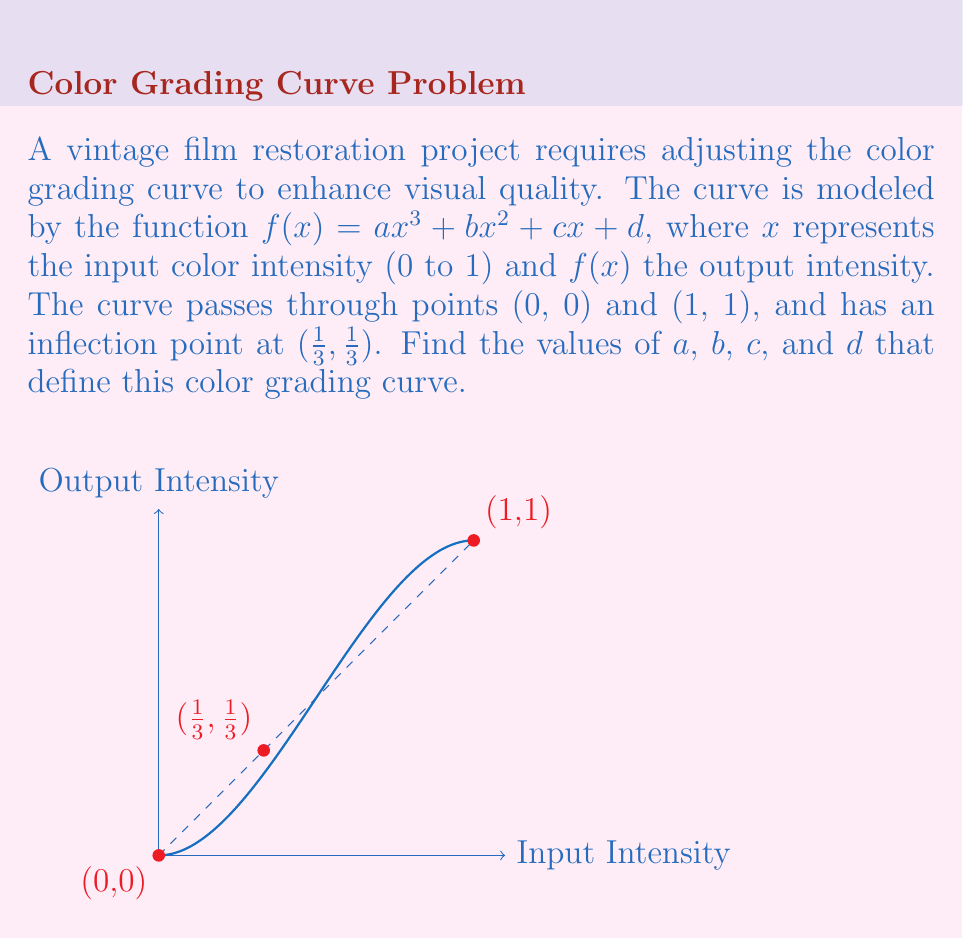Can you solve this math problem? Let's approach this step-by-step:

1) First, we use the condition that the curve passes through (0, 0):
   $f(0) = a(0)^3 + b(0)^2 + c(0) + d = 0$
   This implies $d = 0$

2) Next, we use the condition that the curve passes through (1, 1):
   $f(1) = a(1)^3 + b(1)^2 + c(1) + 0 = 1$
   $a + b + c = 1$ ... (Equation 1)

3) For the inflection point at $(\frac{1}{3}, \frac{1}{3})$, we need:
   $f(\frac{1}{3}) = \frac{1}{3}$
   $a(\frac{1}{3})^3 + b(\frac{1}{3})^2 + c(\frac{1}{3}) = \frac{1}{3}$
   $\frac{a}{27} + \frac{b}{9} + \frac{c}{3} = \frac{1}{3}$ ... (Equation 2)

4) At the inflection point, the second derivative should be zero:
   $f''(x) = 6ax + 2b$
   $f''(\frac{1}{3}) = 6a(\frac{1}{3}) + 2b = 0$
   $2a + 2b = 0$
   $a = -b$ ... (Equation 3)

5) From Equation 3, substitute $b = -a$ into Equation 1:
   $a - a + c = 1$
   $c = 1$ ... (Equation 4)

6) Substitute Equations 3 and 4 into Equation 2:
   $\frac{a}{27} - \frac{a}{9} + \frac{1}{3} = \frac{1}{3}$
   $\frac{a}{27} - \frac{a}{9} = 0$
   $a = -2$

7) From Equation 3, if $a = -2$, then $b = 2$

Therefore, $a = -2$, $b = 2$, $c = 1$, and $d = 0$.
Answer: $a = -2$, $b = 2$, $c = 1$, $d = 0$ 